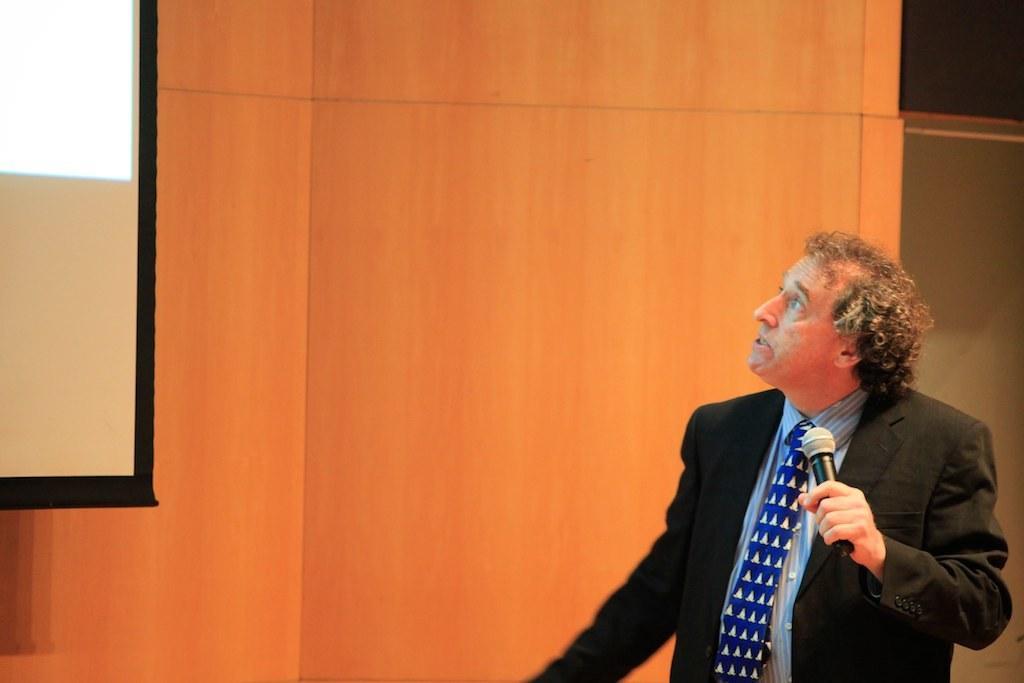Could you give a brief overview of what you see in this image? In the picture we can see a man standing and holding a microphone in the hand and looking towards to the screen which is to the wall and he is in a blazer, tie and shirt. 